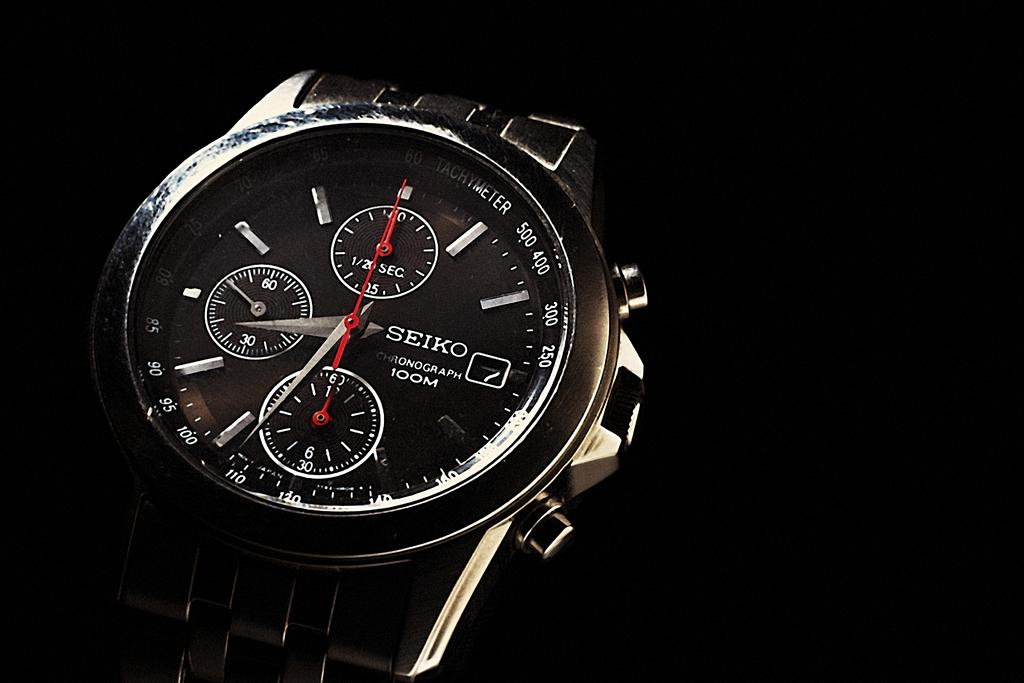<image>
Share a concise interpretation of the image provided. A black luxury Seiko brand watch with a silver chain band. 